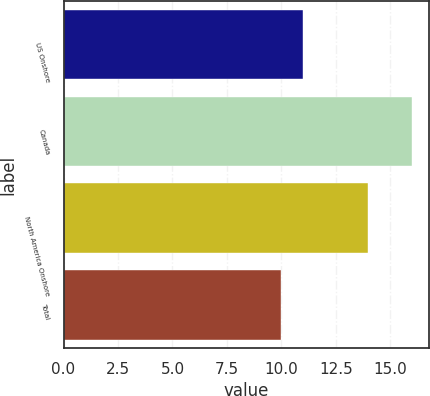Convert chart to OTSL. <chart><loc_0><loc_0><loc_500><loc_500><bar_chart><fcel>US Onshore<fcel>Canada<fcel>North America Onshore<fcel>Total<nl><fcel>11<fcel>16<fcel>14<fcel>10<nl></chart> 